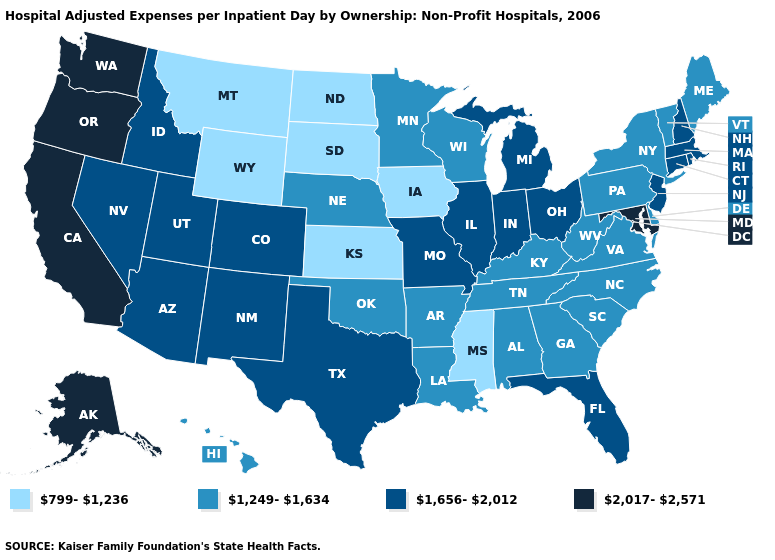Among the states that border Nebraska , which have the highest value?
Write a very short answer. Colorado, Missouri. Among the states that border Indiana , does Michigan have the lowest value?
Short answer required. No. What is the value of California?
Be succinct. 2,017-2,571. Name the states that have a value in the range 1,656-2,012?
Concise answer only. Arizona, Colorado, Connecticut, Florida, Idaho, Illinois, Indiana, Massachusetts, Michigan, Missouri, Nevada, New Hampshire, New Jersey, New Mexico, Ohio, Rhode Island, Texas, Utah. Does Pennsylvania have the highest value in the Northeast?
Be succinct. No. Among the states that border Michigan , does Wisconsin have the highest value?
Answer briefly. No. Name the states that have a value in the range 1,656-2,012?
Quick response, please. Arizona, Colorado, Connecticut, Florida, Idaho, Illinois, Indiana, Massachusetts, Michigan, Missouri, Nevada, New Hampshire, New Jersey, New Mexico, Ohio, Rhode Island, Texas, Utah. Name the states that have a value in the range 799-1,236?
Be succinct. Iowa, Kansas, Mississippi, Montana, North Dakota, South Dakota, Wyoming. Name the states that have a value in the range 2,017-2,571?
Write a very short answer. Alaska, California, Maryland, Oregon, Washington. What is the lowest value in the West?
Keep it brief. 799-1,236. Is the legend a continuous bar?
Concise answer only. No. Does Arizona have the lowest value in the West?
Keep it brief. No. What is the value of Michigan?
Short answer required. 1,656-2,012. Name the states that have a value in the range 1,656-2,012?
Write a very short answer. Arizona, Colorado, Connecticut, Florida, Idaho, Illinois, Indiana, Massachusetts, Michigan, Missouri, Nevada, New Hampshire, New Jersey, New Mexico, Ohio, Rhode Island, Texas, Utah. What is the value of Wisconsin?
Be succinct. 1,249-1,634. 